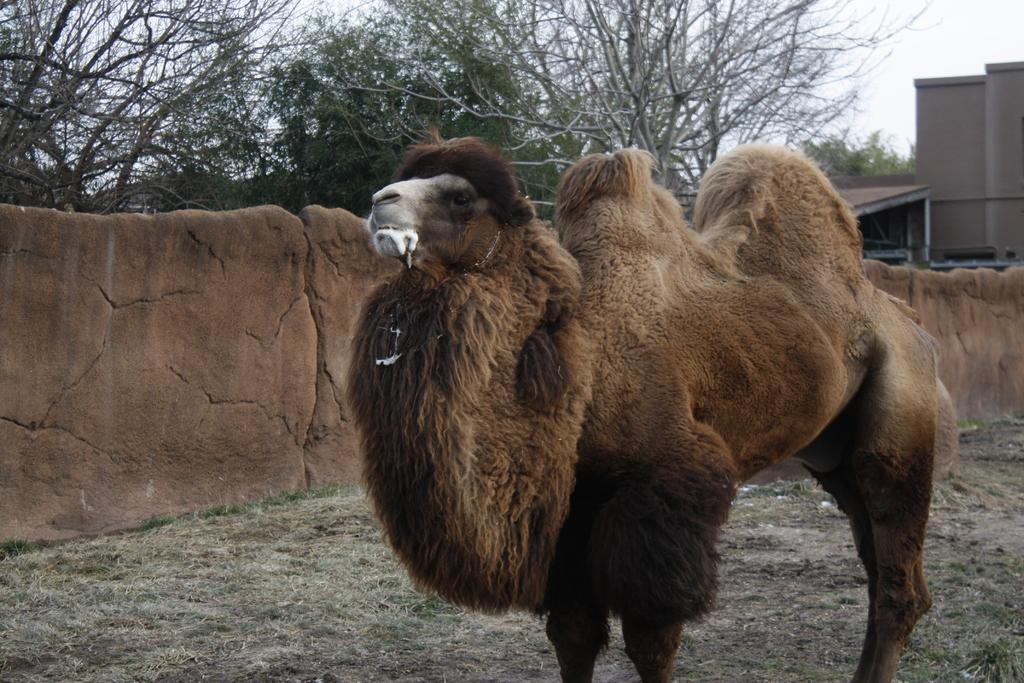What type of animal is in the image? The animal in the image is brown in color. What can be seen in the background of the image? There is a brown building and green trees in the background of the image. What color is the sky in the image? The sky is white in color. How does the animal use the brake while walking in the image? The image does not show the animal using a brake or walking; it is a still image. 